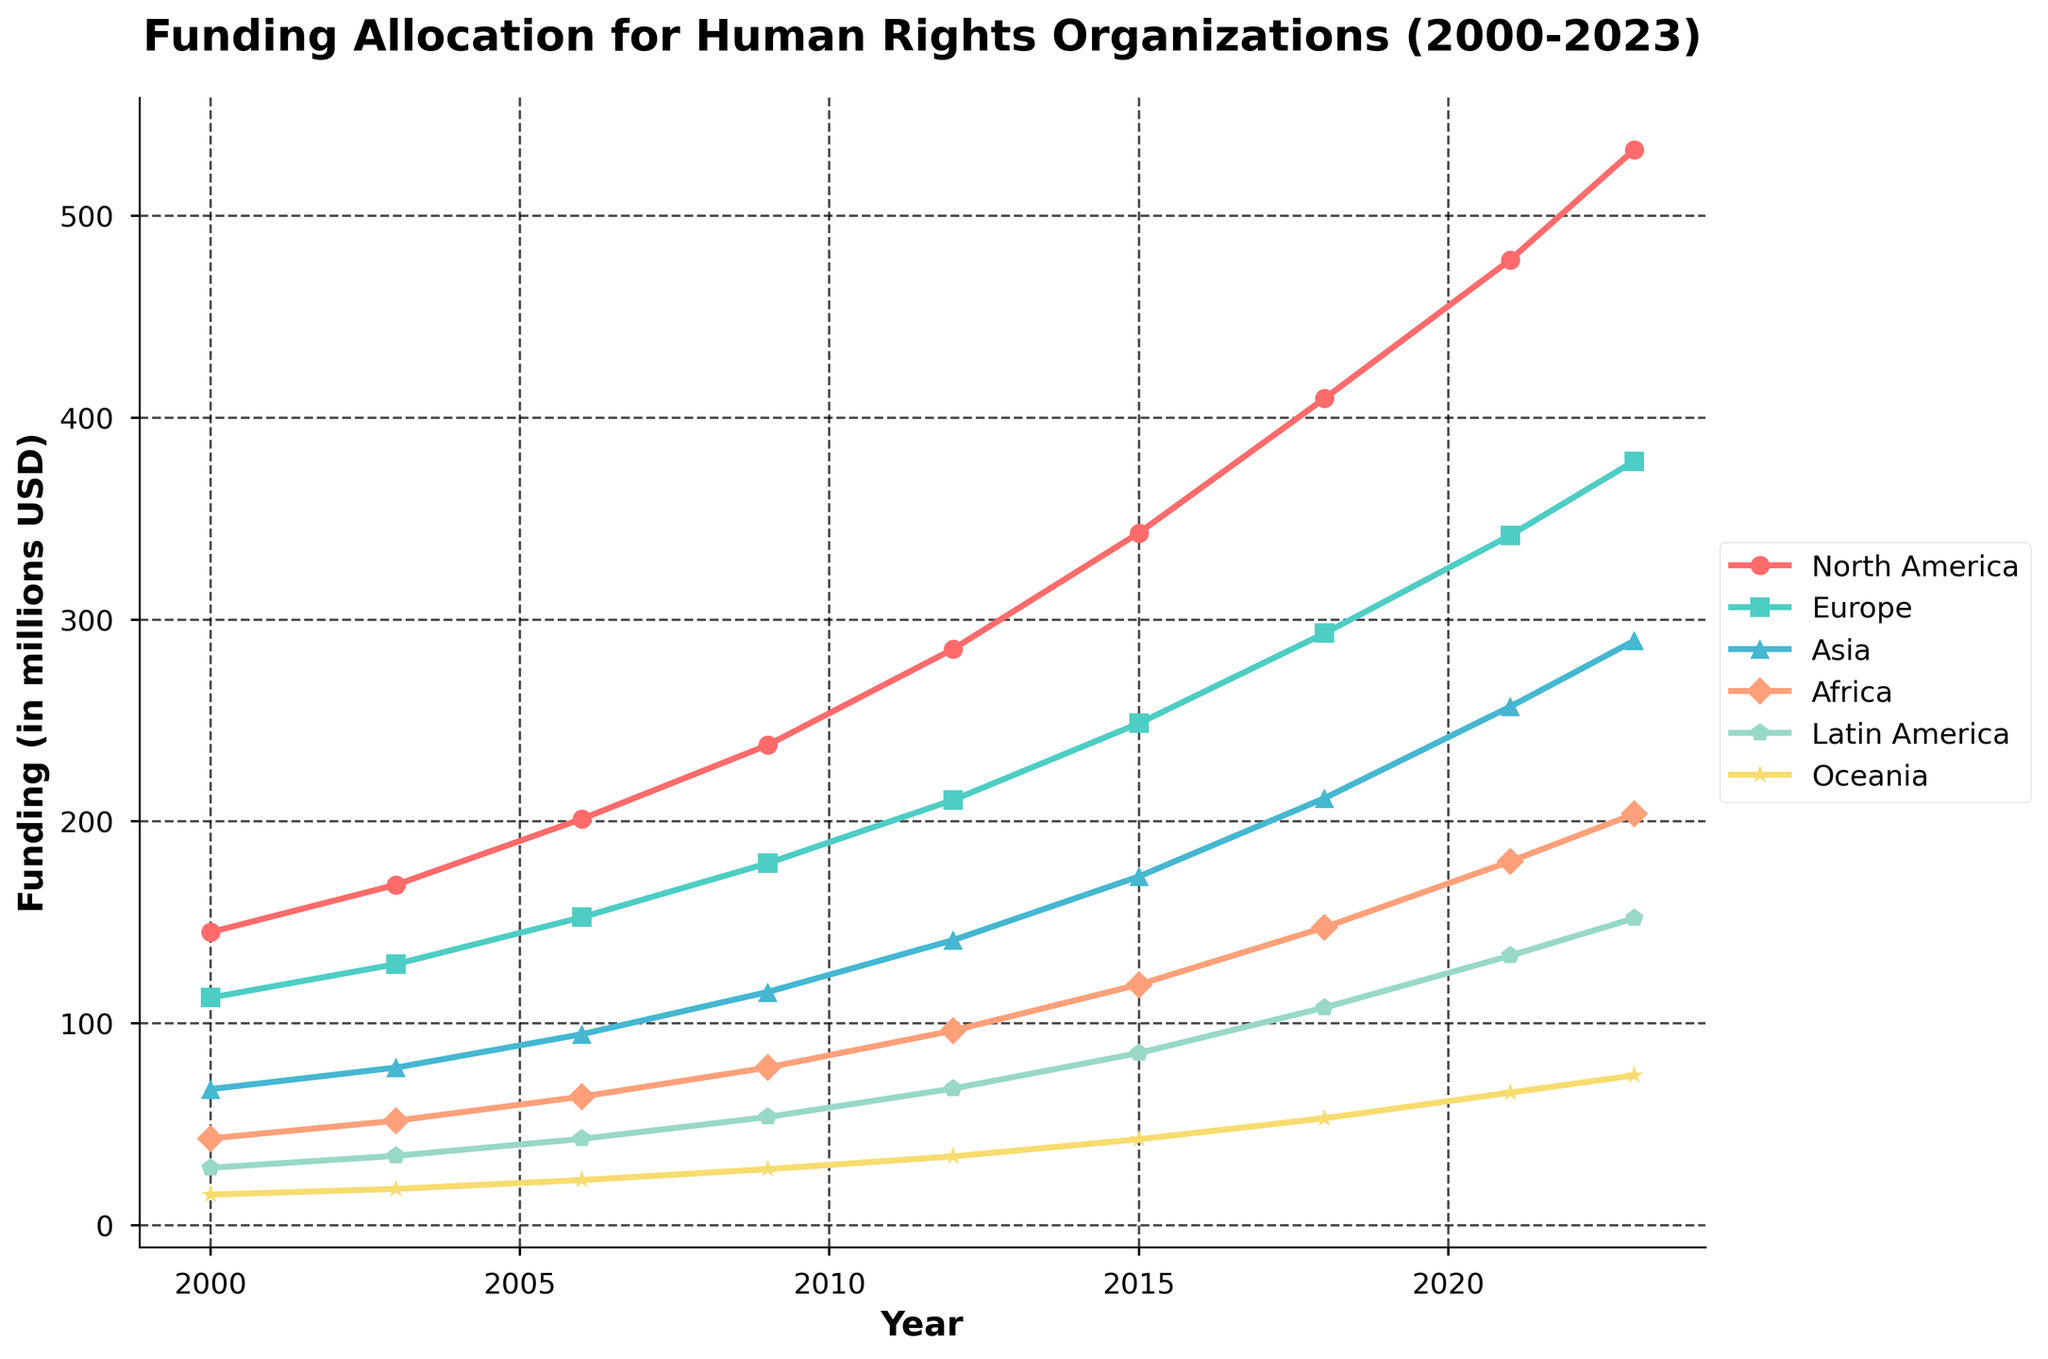What's the trend in funding allocation for Europe from 2000 to 2023? Look at the line representing Europe (in a distinct color like green) and observe its change over time. The line shows a general upward trend.
Answer: Upward trend Which region had the highest funding allocation in 2023? Identify the region with the highest point on the graph in 2023. The highest point corresponds to North America.
Answer: North America How much did the funding for Asia increase from 2000 to 2023? Subtract the 2000 value for Asia (67.5) from the 2023 value for Asia (289.5). The increase is 289.5 - 67.5 = 222.
Answer: 222 million USD Compare the funding trends for Africa and Latin America between 2015 and 2023. Which region saw a greater increase? First, calculate the increase for Africa: 203.7 (2023) - 119.3 (2015) = 84.4. 
Then, calculate the increase for Latin America: 152.1 (2023) - 85.4 (2015) = 66.7. Africa saw a greater increase.
Answer: Africa Which region had the slowest growth in funding from 2000 to 2023? Evaluate the slope of each region's line. Oceania has the lowest slope, indicating the slowest growth.
Answer: Oceania What is the average funding for Europe over the years shown? Sum the funding amounts for Europe: 112.8 + 129.4 + 152.6 + 179.3 + 210.7 + 248.6 + 293.2 + 341.7 + 378.4 = 2046.7. 
Then, divide by the number of years (9). 2046.7 / 9 = 227.4.
Answer: 227.4 million USD How did funding for North America compare to Europe in 2012? Look at the data points in 2012 for North America (285.4) and for Europe (210.7). 
North America had higher funding.
Answer: North America had higher funding What's the combined funding for Asia and Africa in 2021? Add the 2021 funding for Asia (256.9) and Africa (180.3). 
256.9 + 180.3 = 437.2.
Answer: 437.2 million USD By how much did funding for Latin America increase between 2000 and 2009? Subtract the 2000 value for Latin America (28.6) from the 2009 value (53.7). 
53.7 - 28.6 = 25.1.
Answer: 25.1 million USD Which region shows the most consistent growth over the entire period? Identify the line that appears the smoothest and most linear. 
North America's funding line shows the most consistent growth.
Answer: North America 